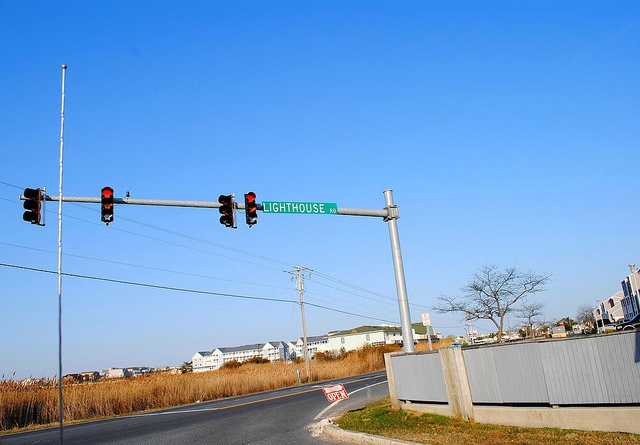Describe the objects in this image and their specific colors. I can see traffic light in gray, black, lightblue, and red tones, traffic light in blue, black, maroon, gray, and brown tones, traffic light in gray, black, lightblue, and darkgray tones, and traffic light in gray, black, red, maroon, and brown tones in this image. 